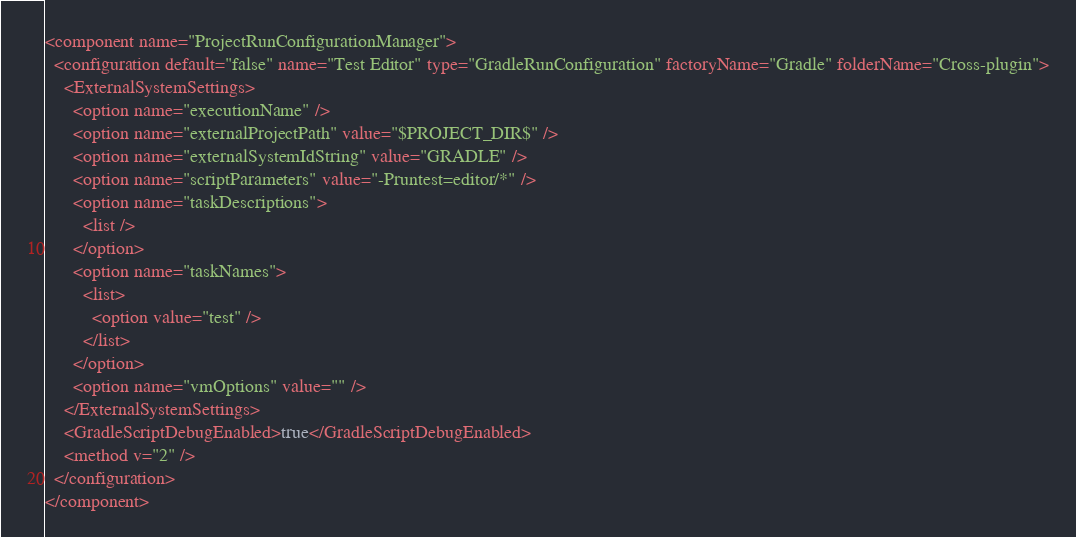<code> <loc_0><loc_0><loc_500><loc_500><_XML_><component name="ProjectRunConfigurationManager">
  <configuration default="false" name="Test Editor" type="GradleRunConfiguration" factoryName="Gradle" folderName="Cross-plugin">
    <ExternalSystemSettings>
      <option name="executionName" />
      <option name="externalProjectPath" value="$PROJECT_DIR$" />
      <option name="externalSystemIdString" value="GRADLE" />
      <option name="scriptParameters" value="-Pruntest=editor/*" />
      <option name="taskDescriptions">
        <list />
      </option>
      <option name="taskNames">
        <list>
          <option value="test" />
        </list>
      </option>
      <option name="vmOptions" value="" />
    </ExternalSystemSettings>
    <GradleScriptDebugEnabled>true</GradleScriptDebugEnabled>
    <method v="2" />
  </configuration>
</component></code> 